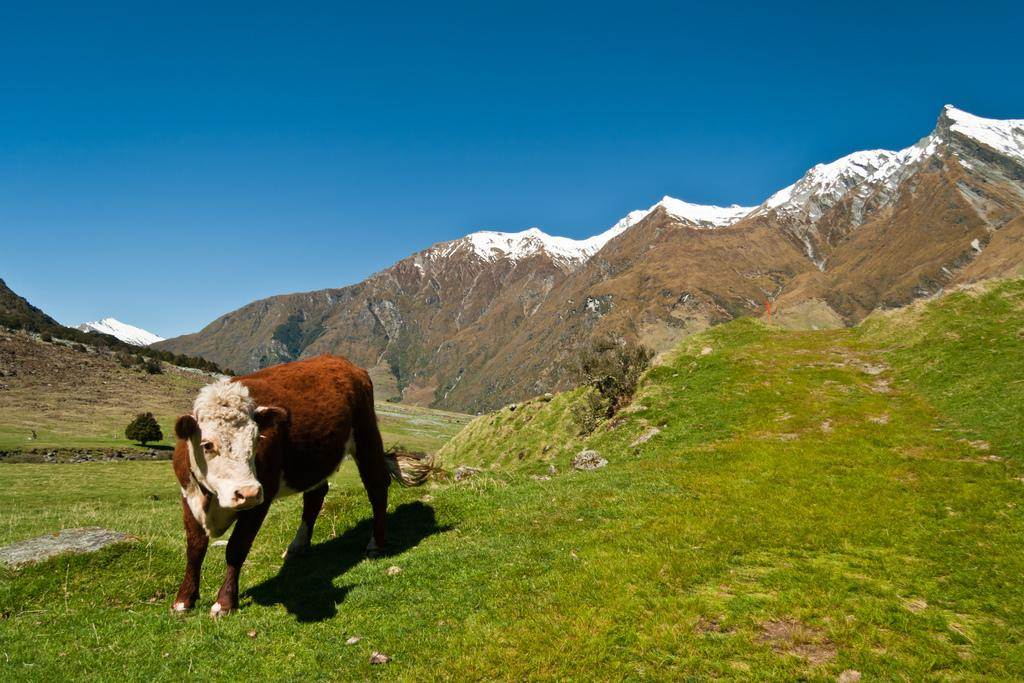What animal is standing in the image? There is a cow standing in the image. Where is the cow standing? The cow is standing on the ground. What is the ground covered with? The ground is covered with grass. What can be seen in the background of the image? There are trees and mountains visible in the background of the image. What is the condition of the sky in the image? The sky is clear in the image. What type of nerve can be seen in the cow's fang in the image? There are no nerves or fangs present in the image; it features a cow standing on grass with trees and mountains in the background. 